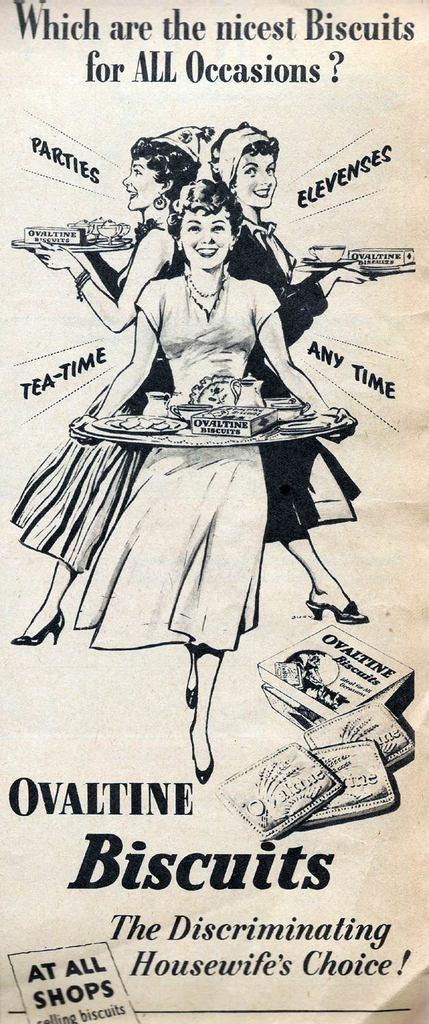What type of paper is present in the image? There is a magazine paper in the image. What is depicted on the magazine paper? The magazine paper contains an image of three women. What are the women doing in the image? The women are standing and holding a plate with food items. What can be found below the image of the three women? There is an advertisement of biscuits under the image. What type of house is visible in the image? There is no house present in the image; it features a magazine paper with an image of three women. What season is depicted in the image? The image does not depict a specific season; it only shows three women standing and holding a plate with food items. 